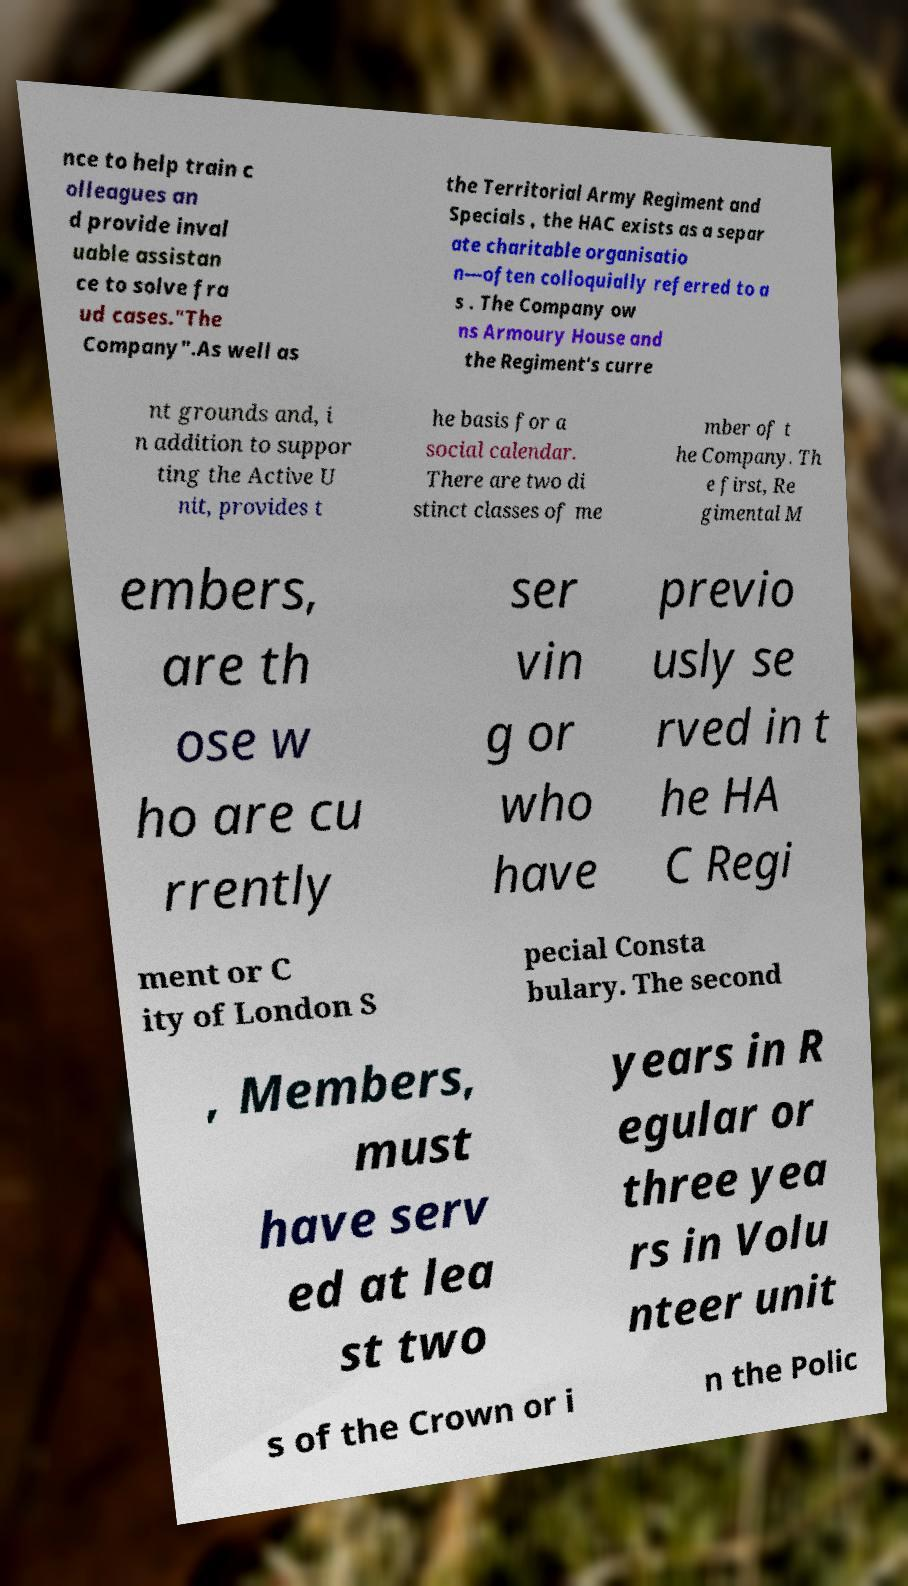Can you read and provide the text displayed in the image?This photo seems to have some interesting text. Can you extract and type it out for me? nce to help train c olleagues an d provide inval uable assistan ce to solve fra ud cases."The Company".As well as the Territorial Army Regiment and Specials , the HAC exists as a separ ate charitable organisatio n—often colloquially referred to a s . The Company ow ns Armoury House and the Regiment's curre nt grounds and, i n addition to suppor ting the Active U nit, provides t he basis for a social calendar. There are two di stinct classes of me mber of t he Company. Th e first, Re gimental M embers, are th ose w ho are cu rrently ser vin g or who have previo usly se rved in t he HA C Regi ment or C ity of London S pecial Consta bulary. The second , Members, must have serv ed at lea st two years in R egular or three yea rs in Volu nteer unit s of the Crown or i n the Polic 